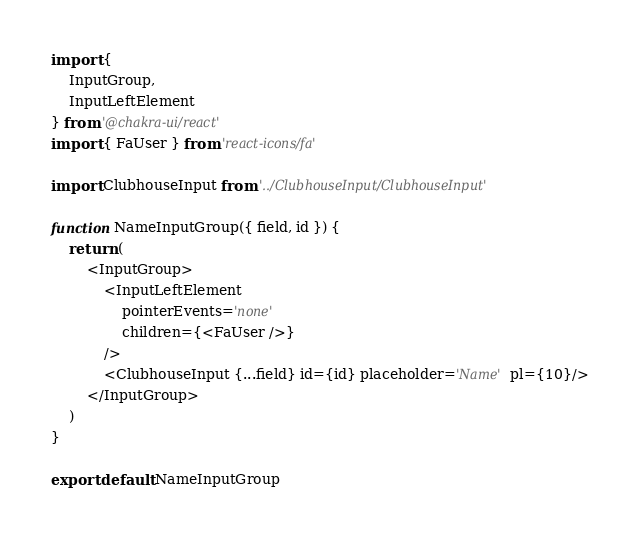<code> <loc_0><loc_0><loc_500><loc_500><_JavaScript_>import {
    InputGroup,
    InputLeftElement
} from '@chakra-ui/react'
import { FaUser } from 'react-icons/fa'

import ClubhouseInput from '../ClubhouseInput/ClubhouseInput'

function NameInputGroup({ field, id }) {
    return (
        <InputGroup>
            <InputLeftElement
                pointerEvents='none'
                children={<FaUser />}
            />
            <ClubhouseInput {...field} id={id} placeholder='Name' pl={10}/>
        </InputGroup>
    )
}

export default NameInputGroup</code> 